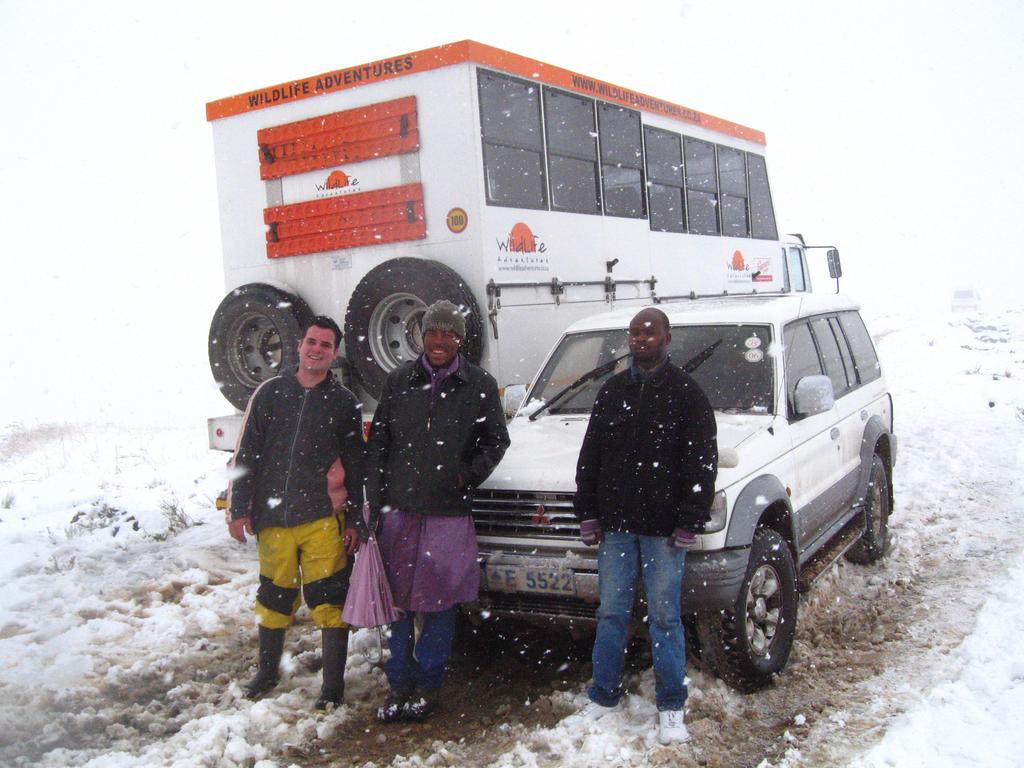How many people are in the image? There are three persons standing in the center of the image. What type of vehicle is in the image? There is a truck in the image. Can you describe the setting of the image? Snow is present at the bottom of the image. What is the name of the person sitting on the seat in the image? There is no person sitting on a seat in the image; all three persons are standing. 